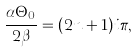Convert formula to latex. <formula><loc_0><loc_0><loc_500><loc_500>\frac { \alpha \Theta _ { 0 } } { 2 \beta } = ( 2 n + 1 ) i \pi ,</formula> 